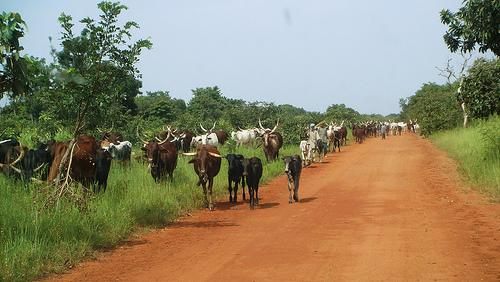Highlight the important activity taking place and the central figures involved in it. Farmhands are moving cattle, including cows, calves, and goats, down a dirt road. List the main elements of the picture without describing their location. Cattle, calves, dirt road, grass, trees, bushes, blue sky, white clouds, farmhands. Briefly summarize the scene depicted in the image. Cattle and calves wander on a dirt road surrounded by grass, trees, and bushes, with farmhands and blue sky with white clouds in the background. Point out the prominent colors of the image and the primary action taking place. The image features a blue sky, white clouds, green grass, and animals like cattle, cows, and goats walking down a dirt road. Mention the primary activity happening in the image and the type of landscape it occurs in. A group of cattle is being herded down a dirt road amidst grass, trees, and bushes under a blue sky with white clouds. Briefly outline the primary subject and background elements in the image. The image features cattle and farmhands on a dirt road, with a backdrop of grass, trees, bushes, and a blue sky with white clouds overhead. Elaborate on the main action occurring in the picture and the key components of the scene. A large group of assorted cattle, cows, calves, and goats are being herded down a dirt road by farmhands, surrounded by green grass, trees, and bushes, under a clear blue sky. Provide a short description of the image, focusing on the weather and overall atmosphere. The image displays a sunny day with a blue sky and white clouds, with cattle and farmhands on a dirt road surrounded by greenery. Describe the environment of the image and the creatures inhabiting it. The image shows a rural landscape with a dirt road, tall grass, trees, and bushes, inhabited by cattle, cows, calves, goats, and farmhands. Identify the main elements of the picture with a focus on animals. Cattle, cows, calves, goats, and farmhands are present in the image on a dirt road, surrounded by trees, grass, and bushes. 